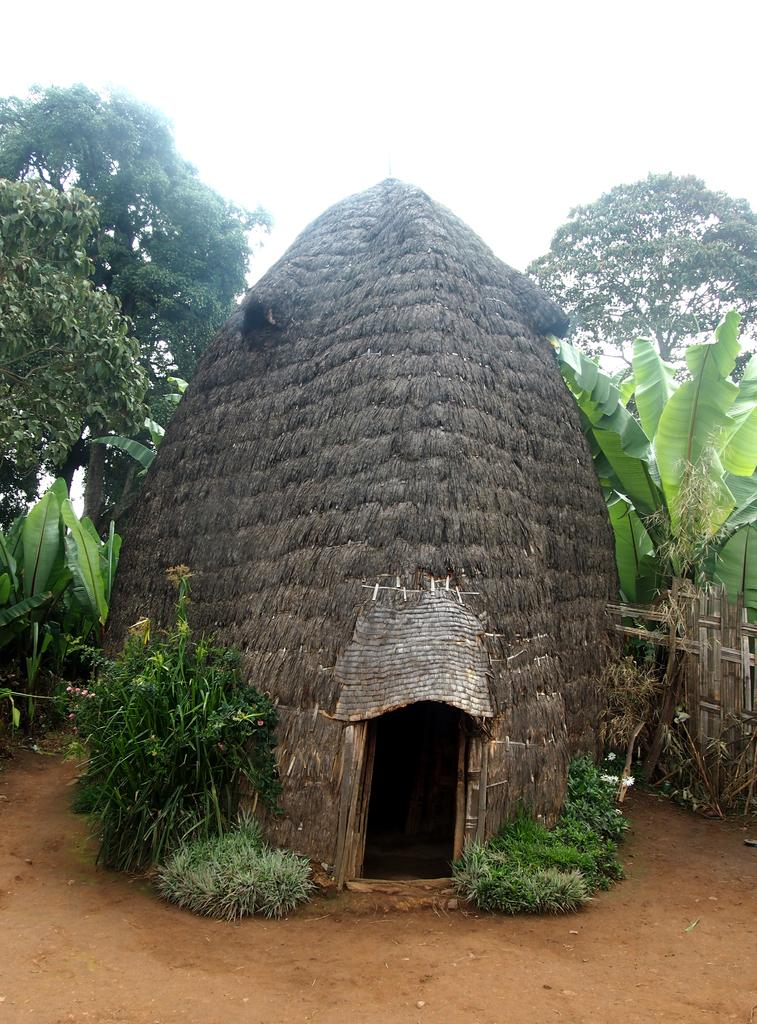What is the main subject of the image? There is a hurt in the image. What type of natural elements can be seen in the image? There are plants and trees in the image. What else is present in the image besides the hurt and natural elements? There are objects in the image. What can be seen in the distance in the image? The sky is visible in the background of the image. What type of rail can be seen in the image? There is no rail present in the image. What treatment is being administered to the hurt in the image? The image does not show any treatment being administered to the hurt; it only shows the hurt itself. 